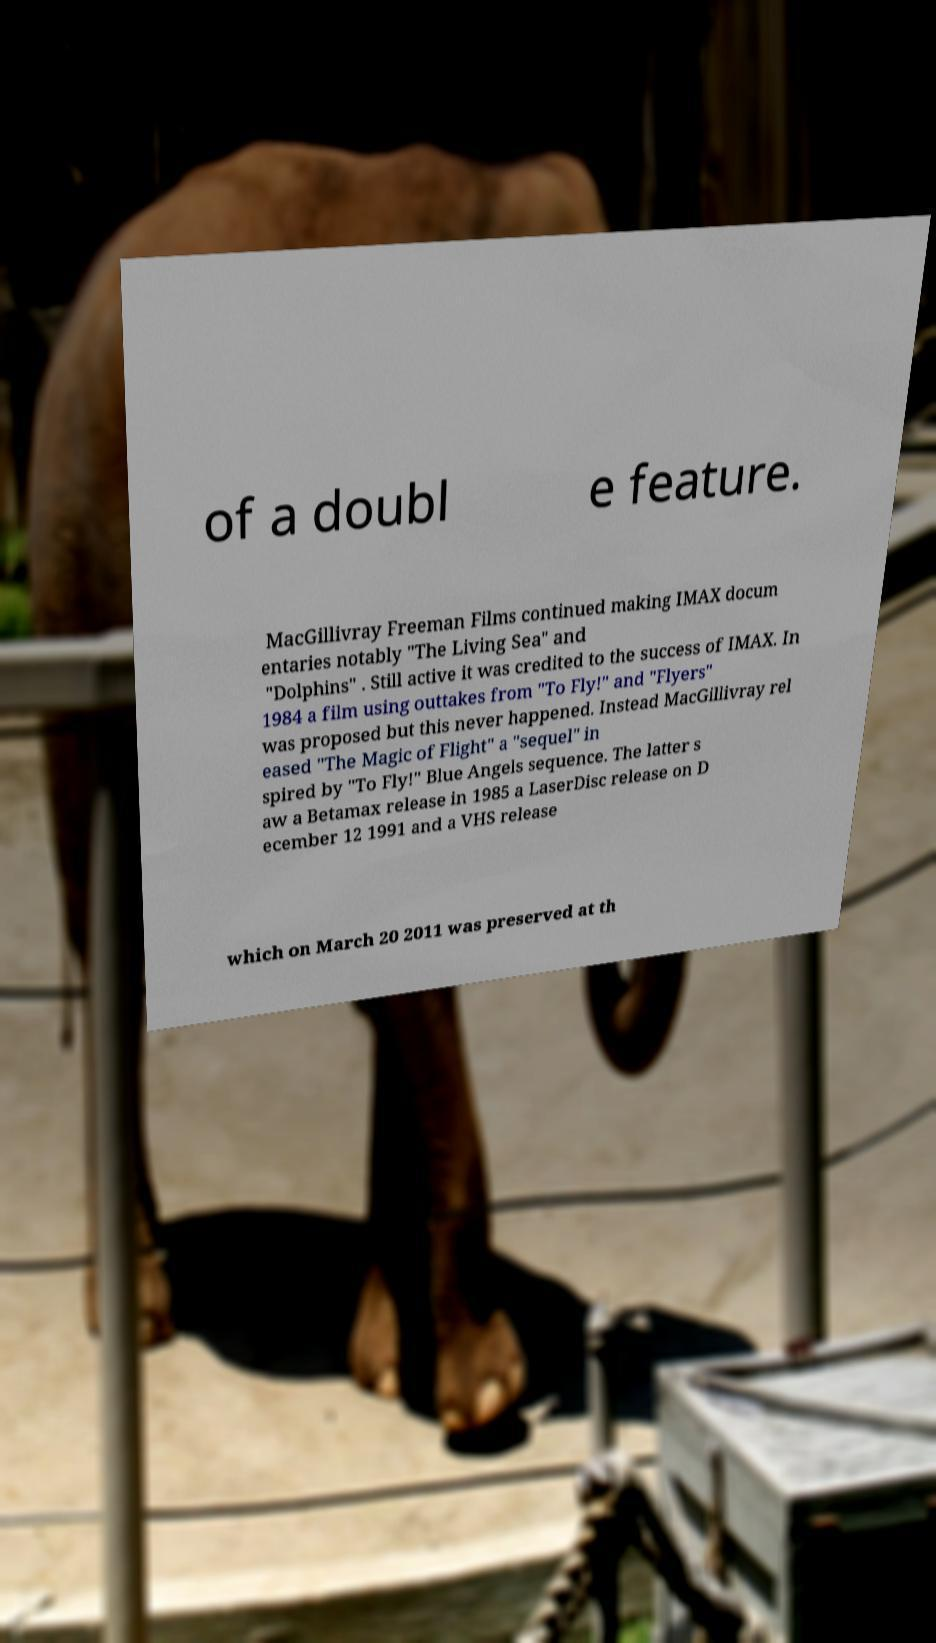Could you assist in decoding the text presented in this image and type it out clearly? of a doubl e feature. MacGillivray Freeman Films continued making IMAX docum entaries notably "The Living Sea" and "Dolphins" . Still active it was credited to the success of IMAX. In 1984 a film using outtakes from "To Fly!" and "Flyers" was proposed but this never happened. Instead MacGillivray rel eased "The Magic of Flight" a "sequel" in spired by "To Fly!" Blue Angels sequence. The latter s aw a Betamax release in 1985 a LaserDisc release on D ecember 12 1991 and a VHS release which on March 20 2011 was preserved at th 